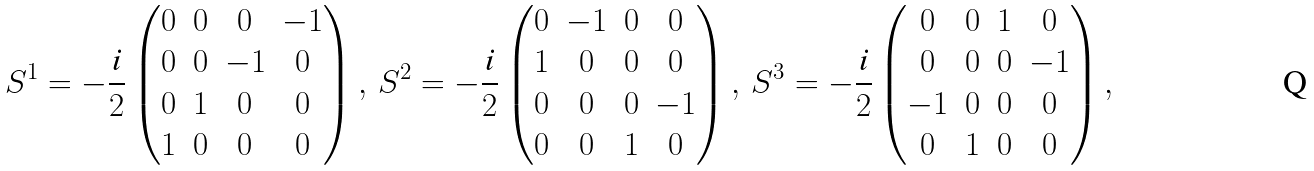Convert formula to latex. <formula><loc_0><loc_0><loc_500><loc_500>S ^ { 1 } = - \frac { \text {i} } { 2 } \begin{pmatrix} 0 & 0 & 0 & - 1 \\ 0 & 0 & - 1 & 0 \\ 0 & 1 & 0 & 0 \\ 1 & 0 & 0 & 0 \end{pmatrix} , \, S ^ { 2 } = - \frac { \text {i} } { 2 } \begin{pmatrix} 0 & - 1 & 0 & 0 \\ 1 & 0 & 0 & 0 \\ 0 & 0 & 0 & - 1 \\ 0 & 0 & 1 & 0 \end{pmatrix} , \, S ^ { 3 } = - \frac { \text {i} } { 2 } \begin{pmatrix} 0 & 0 & 1 & 0 \\ 0 & 0 & 0 & - 1 \\ - 1 & 0 & 0 & 0 \\ 0 & 1 & 0 & 0 \end{pmatrix} ,</formula> 